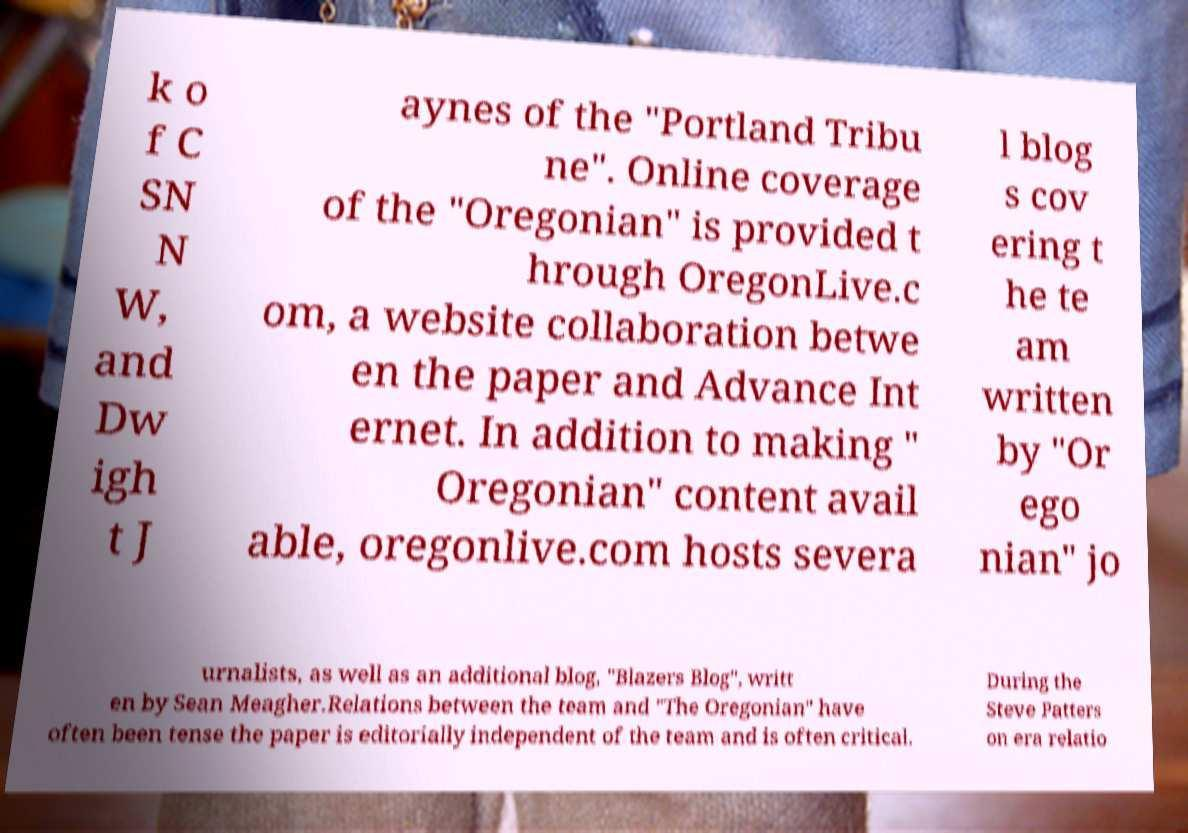For documentation purposes, I need the text within this image transcribed. Could you provide that? k o f C SN N W, and Dw igh t J aynes of the "Portland Tribu ne". Online coverage of the "Oregonian" is provided t hrough OregonLive.c om, a website collaboration betwe en the paper and Advance Int ernet. In addition to making " Oregonian" content avail able, oregonlive.com hosts severa l blog s cov ering t he te am written by "Or ego nian" jo urnalists, as well as an additional blog, "Blazers Blog", writt en by Sean Meagher.Relations between the team and "The Oregonian" have often been tense the paper is editorially independent of the team and is often critical. During the Steve Patters on era relatio 